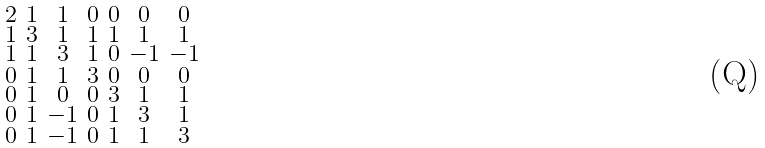Convert formula to latex. <formula><loc_0><loc_0><loc_500><loc_500>\begin{smallmatrix} 2 & 1 & 1 & 0 & 0 & 0 & 0 \\ 1 & 3 & 1 & 1 & 1 & 1 & 1 \\ 1 & 1 & 3 & 1 & 0 & - 1 & - 1 \\ 0 & 1 & 1 & 3 & 0 & 0 & 0 \\ 0 & 1 & 0 & 0 & 3 & 1 & 1 \\ 0 & 1 & - 1 & 0 & 1 & 3 & 1 \\ 0 & 1 & - 1 & 0 & 1 & 1 & 3 \end{smallmatrix}</formula> 